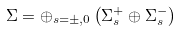<formula> <loc_0><loc_0><loc_500><loc_500>\Sigma = \oplus _ { s = \pm , 0 } \left ( \Sigma _ { s } ^ { + } \oplus \Sigma _ { s } ^ { - } \right )</formula> 